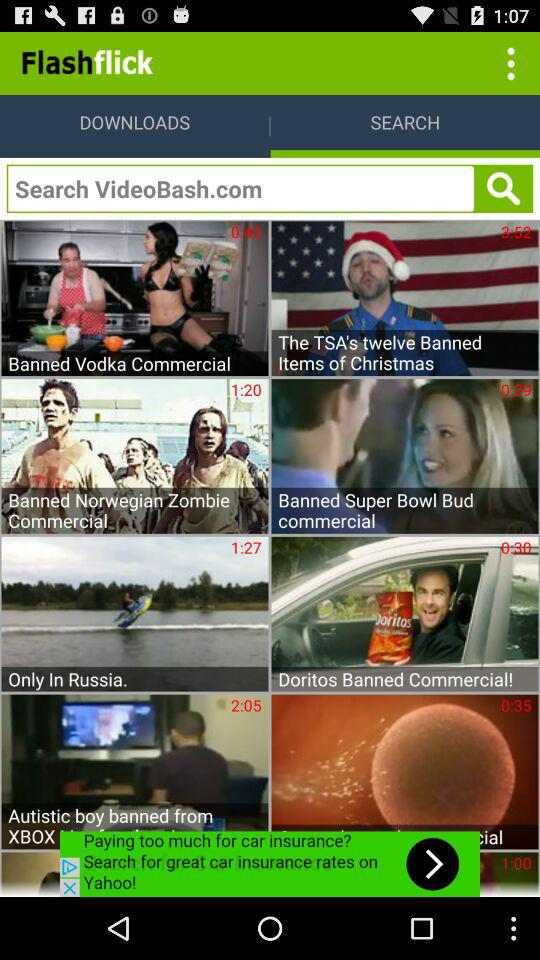What is the developer name? The developer name is "Flashflick". 